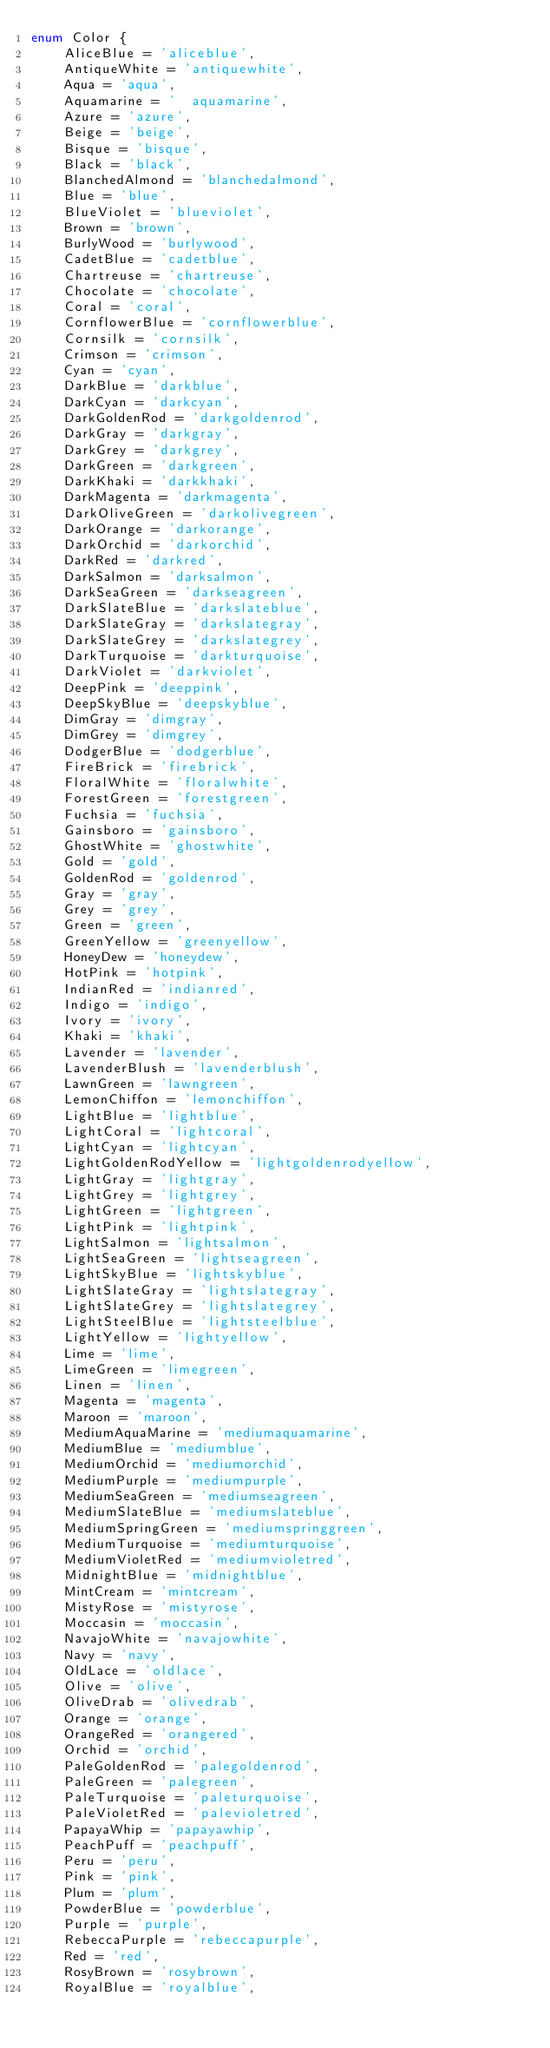Convert code to text. <code><loc_0><loc_0><loc_500><loc_500><_TypeScript_>enum Color {
    AliceBlue = 'aliceblue',
	AntiqueWhite = 'antiquewhite',
	Aqua = 'aqua',
	Aquamarine = '	aquamarine',
	Azure = 'azure',
	Beige = 'beige',
	Bisque = 'bisque',
	Black = 'black',
	BlanchedAlmond = 'blanchedalmond',
	Blue = 'blue',
	BlueViolet = 'blueviolet',
	Brown = 'brown',
	BurlyWood = 'burlywood',
	CadetBlue = 'cadetblue',
	Chartreuse = 'chartreuse',
	Chocolate = 'chocolate',
	Coral = 'coral',
	CornflowerBlue = 'cornflowerblue',
	Cornsilk = 'cornsilk',
	Crimson = 'crimson',
	Cyan = 'cyan',
	DarkBlue = 'darkblue',
	DarkCyan = 'darkcyan',
	DarkGoldenRod = 'darkgoldenrod',
	DarkGray = 'darkgray',
	DarkGrey = 'darkgrey',
	DarkGreen = 'darkgreen',
	DarkKhaki = 'darkkhaki',
	DarkMagenta = 'darkmagenta',
	DarkOliveGreen = 'darkolivegreen',
	DarkOrange = 'darkorange',
	DarkOrchid = 'darkorchid',
	DarkRed = 'darkred',
	DarkSalmon = 'darksalmon',
	DarkSeaGreen = 'darkseagreen',
	DarkSlateBlue = 'darkslateblue',
	DarkSlateGray = 'darkslategray',
	DarkSlateGrey = 'darkslategrey',
	DarkTurquoise = 'darkturquoise',
	DarkViolet = 'darkviolet',
	DeepPink = 'deeppink',
	DeepSkyBlue = 'deepskyblue',
	DimGray = 'dimgray',
	DimGrey = 'dimgrey',
	DodgerBlue = 'dodgerblue',
	FireBrick = 'firebrick',
	FloralWhite = 'floralwhite',
	ForestGreen = 'forestgreen',
	Fuchsia = 'fuchsia',
	Gainsboro = 'gainsboro',
	GhostWhite = 'ghostwhite',
	Gold = 'gold',
	GoldenRod = 'goldenrod',
	Gray = 'gray',
	Grey = 'grey',
	Green = 'green',
	GreenYellow = 'greenyellow',
	HoneyDew = 'honeydew',
	HotPink = 'hotpink',
	IndianRed = 'indianred',
	Indigo = 'indigo',
	Ivory = 'ivory',
	Khaki = 'khaki',
	Lavender = 'lavender',
	LavenderBlush = 'lavenderblush',
	LawnGreen = 'lawngreen',
	LemonChiffon = 'lemonchiffon',
	LightBlue = 'lightblue',
	LightCoral = 'lightcoral',
	LightCyan = 'lightcyan',
	LightGoldenRodYellow = 'lightgoldenrodyellow',
	LightGray = 'lightgray',
	LightGrey = 'lightgrey',
	LightGreen = 'lightgreen',
	LightPink = 'lightpink',
	LightSalmon = 'lightsalmon',
	LightSeaGreen = 'lightseagreen',
	LightSkyBlue = 'lightskyblue',
	LightSlateGray = 'lightslategray',
	LightSlateGrey = 'lightslategrey',
	LightSteelBlue = 'lightsteelblue',
	LightYellow = 'lightyellow',
	Lime = 'lime',
	LimeGreen = 'limegreen',
	Linen = 'linen',
	Magenta = 'magenta',
	Maroon = 'maroon',
	MediumAquaMarine = 'mediumaquamarine',
	MediumBlue = 'mediumblue',
	MediumOrchid = 'mediumorchid',
	MediumPurple = 'mediumpurple',
	MediumSeaGreen = 'mediumseagreen',
	MediumSlateBlue = 'mediumslateblue',
	MediumSpringGreen = 'mediumspringgreen',
	MediumTurquoise = 'mediumturquoise',
	MediumVioletRed = 'mediumvioletred',
	MidnightBlue = 'midnightblue',
	MintCream = 'mintcream',
	MistyRose = 'mistyrose',
	Moccasin = 'moccasin',
	NavajoWhite = 'navajowhite',
	Navy = 'navy',
	OldLace = 'oldlace',
	Olive = 'olive',
	OliveDrab = 'olivedrab',
	Orange = 'orange',
	OrangeRed = 'orangered',
	Orchid = 'orchid',
	PaleGoldenRod = 'palegoldenrod',
	PaleGreen = 'palegreen',
	PaleTurquoise = 'paleturquoise',
	PaleVioletRed = 'palevioletred',
	PapayaWhip = 'papayawhip',
	PeachPuff = 'peachpuff',
	Peru = 'peru',
	Pink = 'pink',
	Plum = 'plum',
	PowderBlue = 'powderblue',
	Purple = 'purple',
	RebeccaPurple = 'rebeccapurple',
	Red = 'red',
	RosyBrown = 'rosybrown',
	RoyalBlue = 'royalblue',</code> 